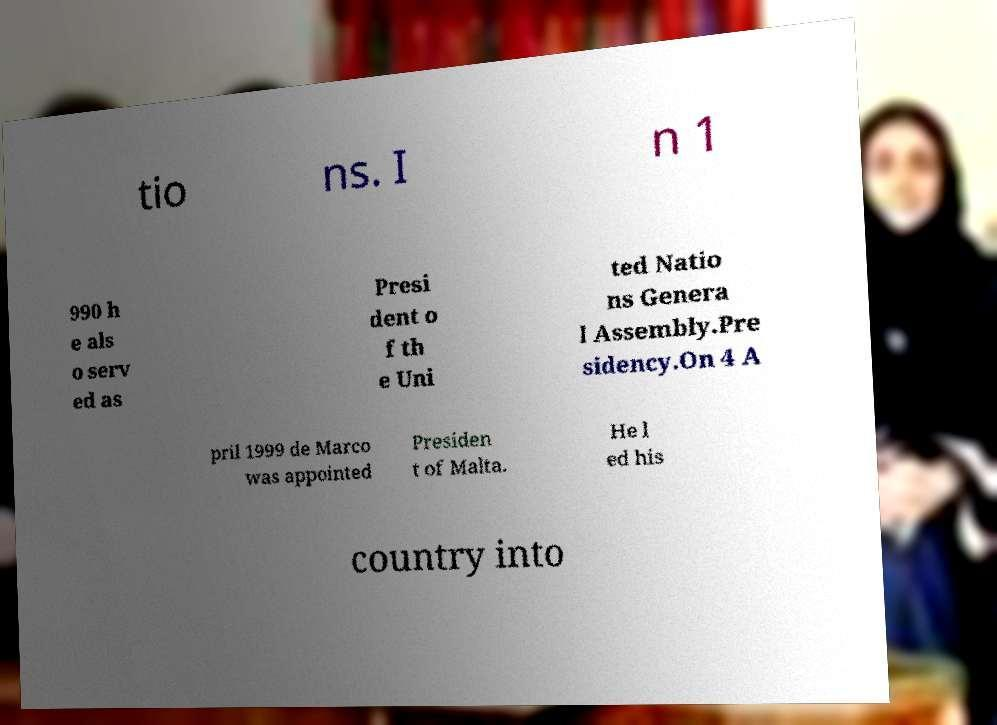Could you assist in decoding the text presented in this image and type it out clearly? tio ns. I n 1 990 h e als o serv ed as Presi dent o f th e Uni ted Natio ns Genera l Assembly.Pre sidency.On 4 A pril 1999 de Marco was appointed Presiden t of Malta. He l ed his country into 